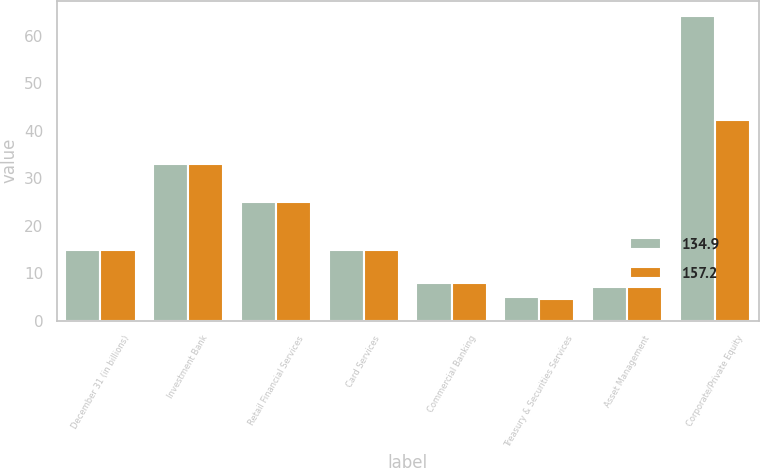<chart> <loc_0><loc_0><loc_500><loc_500><stacked_bar_chart><ecel><fcel>December 31 (in billions)<fcel>Investment Bank<fcel>Retail Financial Services<fcel>Card Services<fcel>Commercial Banking<fcel>Treasury & Securities Services<fcel>Asset Management<fcel>Corporate/Private Equity<nl><fcel>134.9<fcel>15<fcel>33<fcel>25<fcel>15<fcel>8<fcel>5<fcel>7<fcel>64.2<nl><fcel>157.2<fcel>15<fcel>33<fcel>25<fcel>15<fcel>8<fcel>4.5<fcel>7<fcel>42.4<nl></chart> 